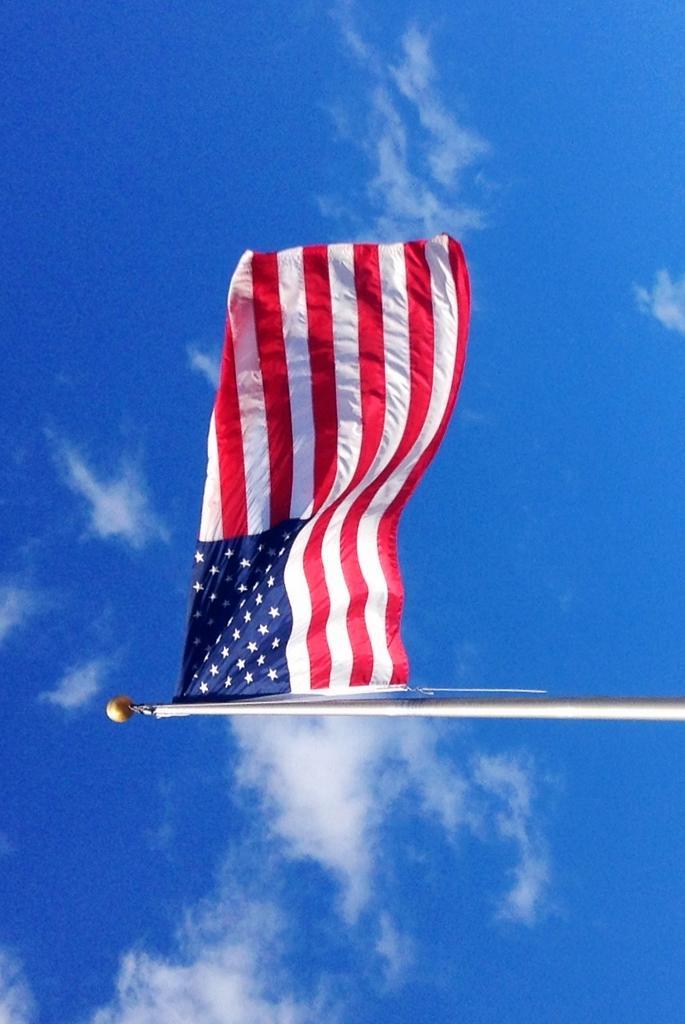Describe this image in one or two sentences. In this image I can see a flag attached to the stand , there is the sky visible in the middle. 